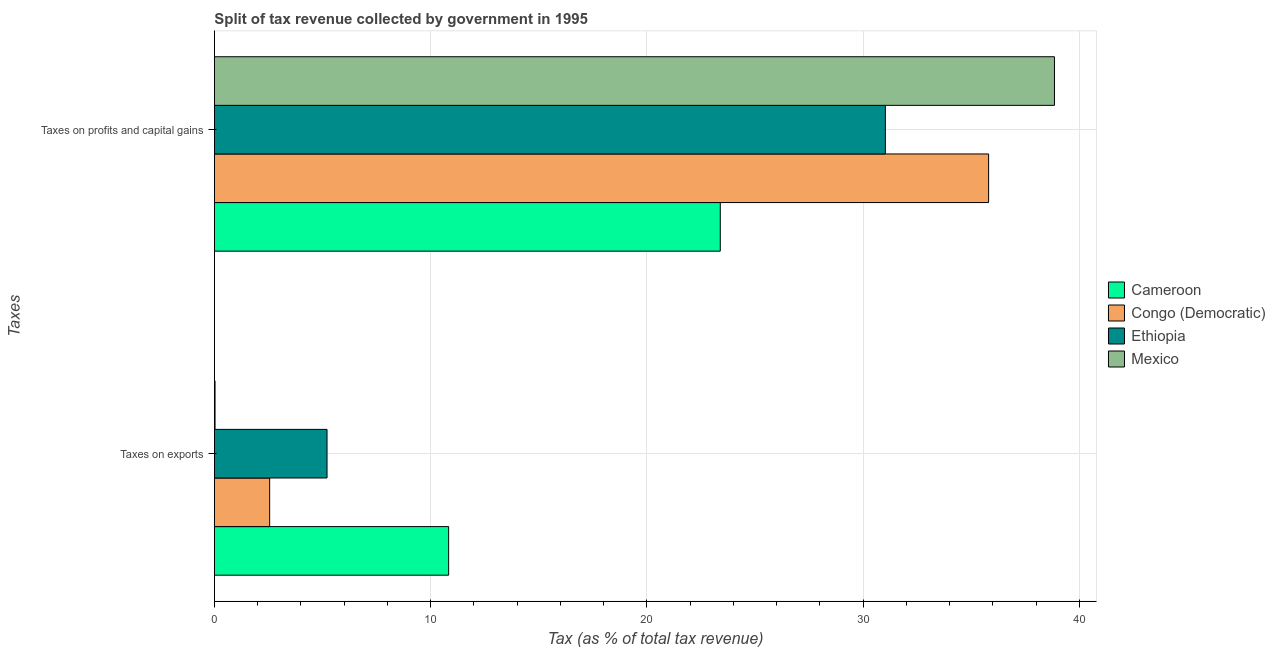How many different coloured bars are there?
Give a very brief answer. 4. How many groups of bars are there?
Make the answer very short. 2. Are the number of bars on each tick of the Y-axis equal?
Give a very brief answer. Yes. What is the label of the 2nd group of bars from the top?
Make the answer very short. Taxes on exports. What is the percentage of revenue obtained from taxes on exports in Ethiopia?
Keep it short and to the point. 5.21. Across all countries, what is the maximum percentage of revenue obtained from taxes on exports?
Your response must be concise. 10.83. Across all countries, what is the minimum percentage of revenue obtained from taxes on exports?
Your answer should be very brief. 0.03. In which country was the percentage of revenue obtained from taxes on exports maximum?
Your answer should be very brief. Cameroon. What is the total percentage of revenue obtained from taxes on exports in the graph?
Keep it short and to the point. 18.64. What is the difference between the percentage of revenue obtained from taxes on profits and capital gains in Mexico and that in Congo (Democratic)?
Give a very brief answer. 3.04. What is the difference between the percentage of revenue obtained from taxes on exports in Cameroon and the percentage of revenue obtained from taxes on profits and capital gains in Mexico?
Ensure brevity in your answer.  -28.02. What is the average percentage of revenue obtained from taxes on exports per country?
Offer a very short reply. 4.66. What is the difference between the percentage of revenue obtained from taxes on exports and percentage of revenue obtained from taxes on profits and capital gains in Ethiopia?
Your answer should be very brief. -25.82. What is the ratio of the percentage of revenue obtained from taxes on profits and capital gains in Ethiopia to that in Mexico?
Offer a very short reply. 0.8. In how many countries, is the percentage of revenue obtained from taxes on profits and capital gains greater than the average percentage of revenue obtained from taxes on profits and capital gains taken over all countries?
Offer a very short reply. 2. What does the 4th bar from the bottom in Taxes on profits and capital gains represents?
Your response must be concise. Mexico. How many bars are there?
Ensure brevity in your answer.  8. What is the difference between two consecutive major ticks on the X-axis?
Ensure brevity in your answer.  10. Are the values on the major ticks of X-axis written in scientific E-notation?
Give a very brief answer. No. How many legend labels are there?
Give a very brief answer. 4. What is the title of the graph?
Make the answer very short. Split of tax revenue collected by government in 1995. What is the label or title of the X-axis?
Your answer should be very brief. Tax (as % of total tax revenue). What is the label or title of the Y-axis?
Your response must be concise. Taxes. What is the Tax (as % of total tax revenue) of Cameroon in Taxes on exports?
Your answer should be compact. 10.83. What is the Tax (as % of total tax revenue) in Congo (Democratic) in Taxes on exports?
Offer a terse response. 2.56. What is the Tax (as % of total tax revenue) of Ethiopia in Taxes on exports?
Provide a short and direct response. 5.21. What is the Tax (as % of total tax revenue) of Mexico in Taxes on exports?
Your response must be concise. 0.03. What is the Tax (as % of total tax revenue) in Cameroon in Taxes on profits and capital gains?
Make the answer very short. 23.4. What is the Tax (as % of total tax revenue) of Congo (Democratic) in Taxes on profits and capital gains?
Provide a succinct answer. 35.81. What is the Tax (as % of total tax revenue) of Ethiopia in Taxes on profits and capital gains?
Make the answer very short. 31.03. What is the Tax (as % of total tax revenue) in Mexico in Taxes on profits and capital gains?
Offer a terse response. 38.85. Across all Taxes, what is the maximum Tax (as % of total tax revenue) of Cameroon?
Provide a succinct answer. 23.4. Across all Taxes, what is the maximum Tax (as % of total tax revenue) of Congo (Democratic)?
Offer a very short reply. 35.81. Across all Taxes, what is the maximum Tax (as % of total tax revenue) of Ethiopia?
Your response must be concise. 31.03. Across all Taxes, what is the maximum Tax (as % of total tax revenue) of Mexico?
Your answer should be very brief. 38.85. Across all Taxes, what is the minimum Tax (as % of total tax revenue) of Cameroon?
Provide a succinct answer. 10.83. Across all Taxes, what is the minimum Tax (as % of total tax revenue) in Congo (Democratic)?
Give a very brief answer. 2.56. Across all Taxes, what is the minimum Tax (as % of total tax revenue) of Ethiopia?
Offer a very short reply. 5.21. Across all Taxes, what is the minimum Tax (as % of total tax revenue) in Mexico?
Give a very brief answer. 0.03. What is the total Tax (as % of total tax revenue) in Cameroon in the graph?
Provide a short and direct response. 34.23. What is the total Tax (as % of total tax revenue) of Congo (Democratic) in the graph?
Keep it short and to the point. 38.36. What is the total Tax (as % of total tax revenue) in Ethiopia in the graph?
Provide a succinct answer. 36.24. What is the total Tax (as % of total tax revenue) of Mexico in the graph?
Your answer should be compact. 38.88. What is the difference between the Tax (as % of total tax revenue) of Cameroon in Taxes on exports and that in Taxes on profits and capital gains?
Ensure brevity in your answer.  -12.56. What is the difference between the Tax (as % of total tax revenue) of Congo (Democratic) in Taxes on exports and that in Taxes on profits and capital gains?
Offer a very short reply. -33.25. What is the difference between the Tax (as % of total tax revenue) in Ethiopia in Taxes on exports and that in Taxes on profits and capital gains?
Your response must be concise. -25.82. What is the difference between the Tax (as % of total tax revenue) of Mexico in Taxes on exports and that in Taxes on profits and capital gains?
Give a very brief answer. -38.82. What is the difference between the Tax (as % of total tax revenue) in Cameroon in Taxes on exports and the Tax (as % of total tax revenue) in Congo (Democratic) in Taxes on profits and capital gains?
Provide a succinct answer. -24.97. What is the difference between the Tax (as % of total tax revenue) in Cameroon in Taxes on exports and the Tax (as % of total tax revenue) in Ethiopia in Taxes on profits and capital gains?
Your answer should be compact. -20.2. What is the difference between the Tax (as % of total tax revenue) in Cameroon in Taxes on exports and the Tax (as % of total tax revenue) in Mexico in Taxes on profits and capital gains?
Your response must be concise. -28.02. What is the difference between the Tax (as % of total tax revenue) of Congo (Democratic) in Taxes on exports and the Tax (as % of total tax revenue) of Ethiopia in Taxes on profits and capital gains?
Provide a succinct answer. -28.47. What is the difference between the Tax (as % of total tax revenue) of Congo (Democratic) in Taxes on exports and the Tax (as % of total tax revenue) of Mexico in Taxes on profits and capital gains?
Give a very brief answer. -36.29. What is the difference between the Tax (as % of total tax revenue) of Ethiopia in Taxes on exports and the Tax (as % of total tax revenue) of Mexico in Taxes on profits and capital gains?
Keep it short and to the point. -33.64. What is the average Tax (as % of total tax revenue) in Cameroon per Taxes?
Your answer should be compact. 17.12. What is the average Tax (as % of total tax revenue) in Congo (Democratic) per Taxes?
Your answer should be compact. 19.18. What is the average Tax (as % of total tax revenue) of Ethiopia per Taxes?
Your response must be concise. 18.12. What is the average Tax (as % of total tax revenue) in Mexico per Taxes?
Ensure brevity in your answer.  19.44. What is the difference between the Tax (as % of total tax revenue) of Cameroon and Tax (as % of total tax revenue) of Congo (Democratic) in Taxes on exports?
Keep it short and to the point. 8.28. What is the difference between the Tax (as % of total tax revenue) of Cameroon and Tax (as % of total tax revenue) of Ethiopia in Taxes on exports?
Provide a short and direct response. 5.62. What is the difference between the Tax (as % of total tax revenue) in Cameroon and Tax (as % of total tax revenue) in Mexico in Taxes on exports?
Ensure brevity in your answer.  10.8. What is the difference between the Tax (as % of total tax revenue) in Congo (Democratic) and Tax (as % of total tax revenue) in Ethiopia in Taxes on exports?
Offer a very short reply. -2.65. What is the difference between the Tax (as % of total tax revenue) of Congo (Democratic) and Tax (as % of total tax revenue) of Mexico in Taxes on exports?
Provide a succinct answer. 2.53. What is the difference between the Tax (as % of total tax revenue) in Ethiopia and Tax (as % of total tax revenue) in Mexico in Taxes on exports?
Ensure brevity in your answer.  5.18. What is the difference between the Tax (as % of total tax revenue) of Cameroon and Tax (as % of total tax revenue) of Congo (Democratic) in Taxes on profits and capital gains?
Your response must be concise. -12.41. What is the difference between the Tax (as % of total tax revenue) of Cameroon and Tax (as % of total tax revenue) of Ethiopia in Taxes on profits and capital gains?
Offer a terse response. -7.63. What is the difference between the Tax (as % of total tax revenue) of Cameroon and Tax (as % of total tax revenue) of Mexico in Taxes on profits and capital gains?
Offer a terse response. -15.45. What is the difference between the Tax (as % of total tax revenue) of Congo (Democratic) and Tax (as % of total tax revenue) of Ethiopia in Taxes on profits and capital gains?
Your answer should be compact. 4.77. What is the difference between the Tax (as % of total tax revenue) in Congo (Democratic) and Tax (as % of total tax revenue) in Mexico in Taxes on profits and capital gains?
Provide a short and direct response. -3.04. What is the difference between the Tax (as % of total tax revenue) in Ethiopia and Tax (as % of total tax revenue) in Mexico in Taxes on profits and capital gains?
Ensure brevity in your answer.  -7.82. What is the ratio of the Tax (as % of total tax revenue) of Cameroon in Taxes on exports to that in Taxes on profits and capital gains?
Your answer should be compact. 0.46. What is the ratio of the Tax (as % of total tax revenue) in Congo (Democratic) in Taxes on exports to that in Taxes on profits and capital gains?
Provide a succinct answer. 0.07. What is the ratio of the Tax (as % of total tax revenue) in Ethiopia in Taxes on exports to that in Taxes on profits and capital gains?
Your answer should be compact. 0.17. What is the ratio of the Tax (as % of total tax revenue) of Mexico in Taxes on exports to that in Taxes on profits and capital gains?
Make the answer very short. 0. What is the difference between the highest and the second highest Tax (as % of total tax revenue) in Cameroon?
Offer a terse response. 12.56. What is the difference between the highest and the second highest Tax (as % of total tax revenue) of Congo (Democratic)?
Keep it short and to the point. 33.25. What is the difference between the highest and the second highest Tax (as % of total tax revenue) in Ethiopia?
Your response must be concise. 25.82. What is the difference between the highest and the second highest Tax (as % of total tax revenue) of Mexico?
Your answer should be compact. 38.82. What is the difference between the highest and the lowest Tax (as % of total tax revenue) in Cameroon?
Offer a very short reply. 12.56. What is the difference between the highest and the lowest Tax (as % of total tax revenue) in Congo (Democratic)?
Provide a short and direct response. 33.25. What is the difference between the highest and the lowest Tax (as % of total tax revenue) in Ethiopia?
Your answer should be compact. 25.82. What is the difference between the highest and the lowest Tax (as % of total tax revenue) of Mexico?
Give a very brief answer. 38.82. 